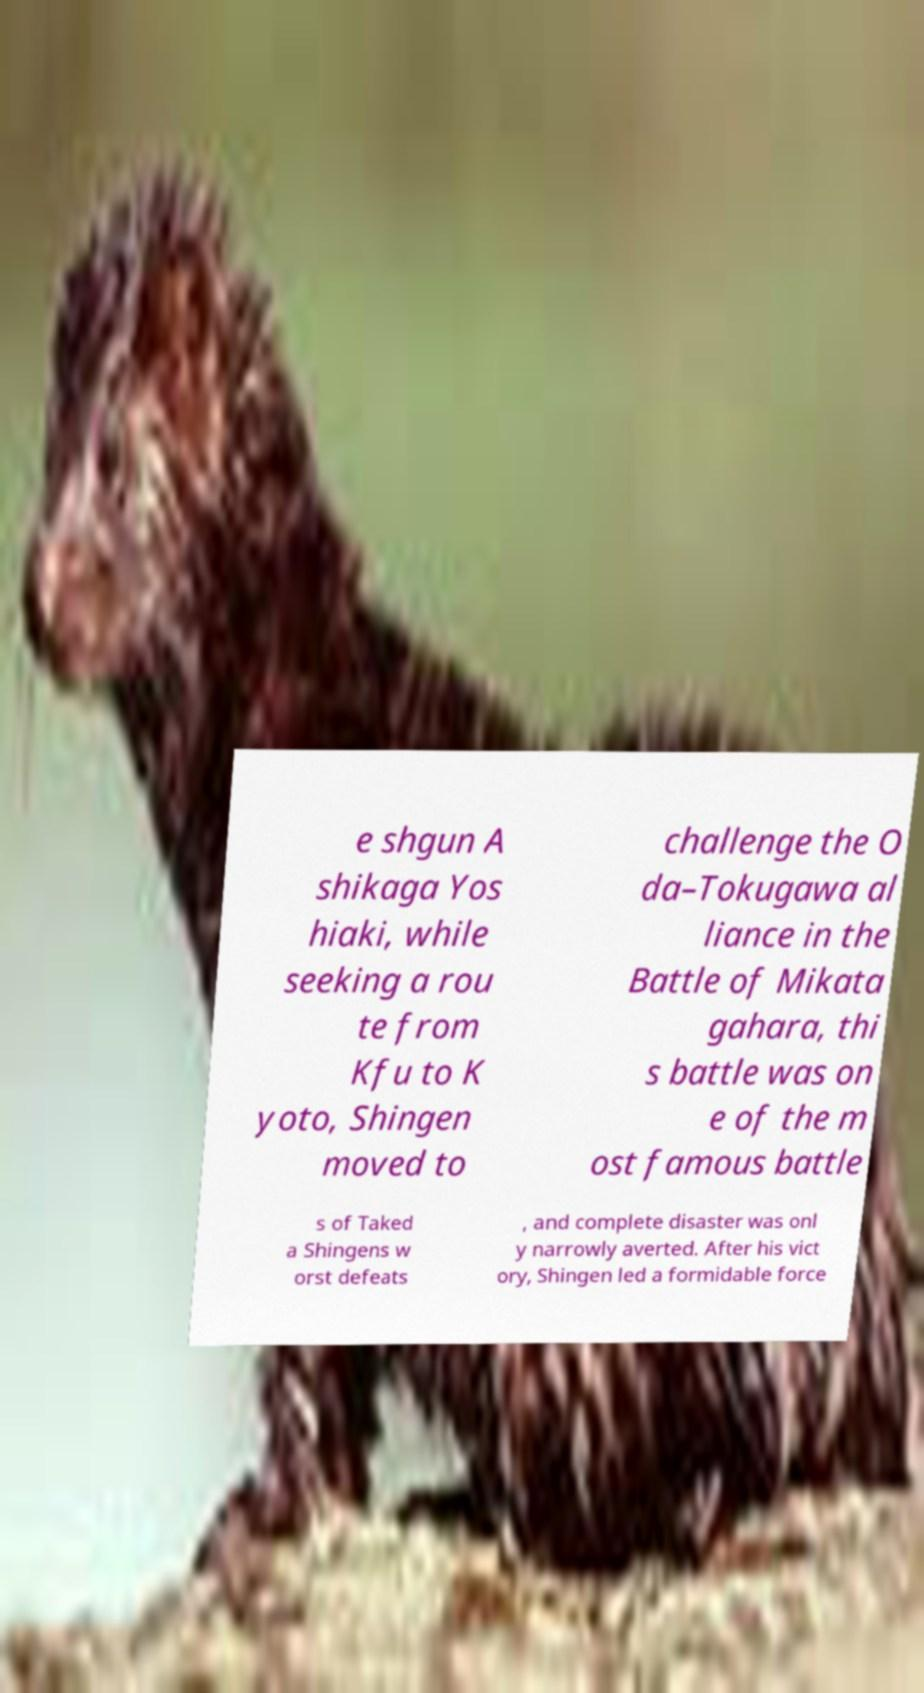Can you accurately transcribe the text from the provided image for me? e shgun A shikaga Yos hiaki, while seeking a rou te from Kfu to K yoto, Shingen moved to challenge the O da–Tokugawa al liance in the Battle of Mikata gahara, thi s battle was on e of the m ost famous battle s of Taked a Shingens w orst defeats , and complete disaster was onl y narrowly averted. After his vict ory, Shingen led a formidable force 